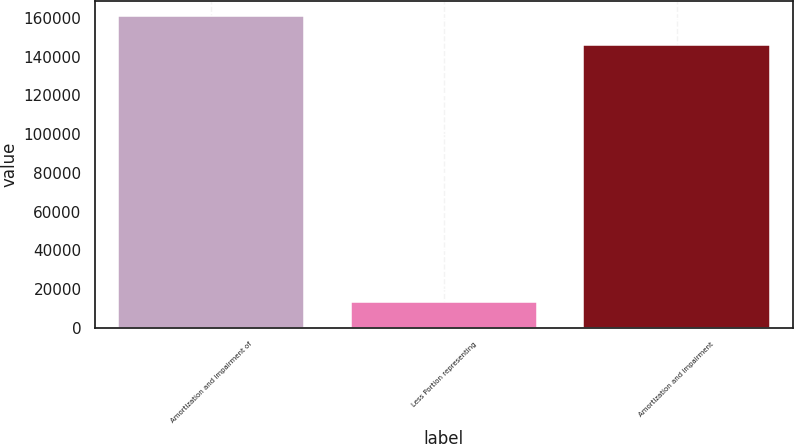<chart> <loc_0><loc_0><loc_500><loc_500><bar_chart><fcel>Amortization and impairment of<fcel>Less Portion representing<fcel>Amortization and impairment<nl><fcel>160712<fcel>13461<fcel>146102<nl></chart> 